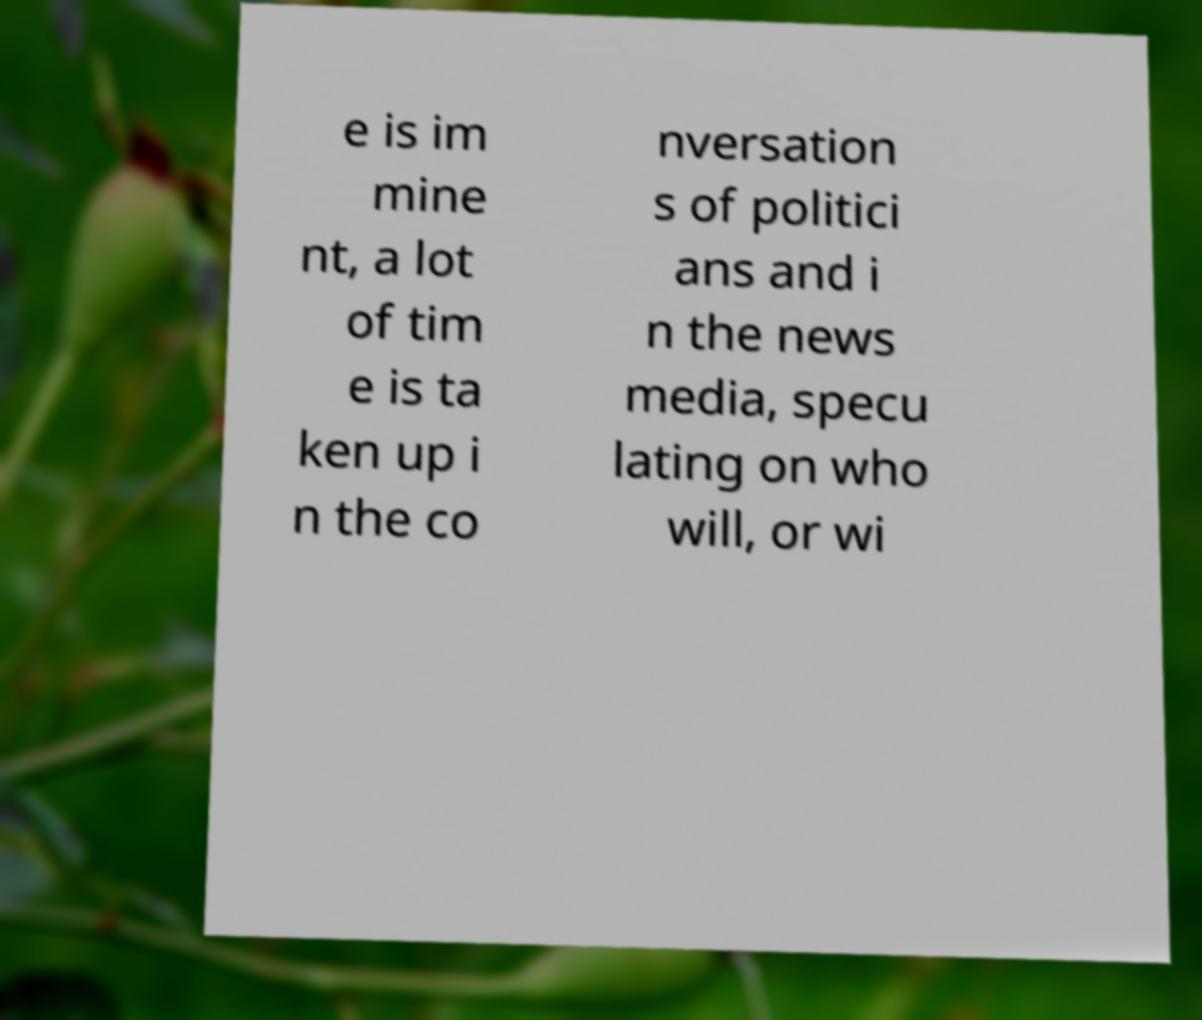For documentation purposes, I need the text within this image transcribed. Could you provide that? e is im mine nt, a lot of tim e is ta ken up i n the co nversation s of politici ans and i n the news media, specu lating on who will, or wi 